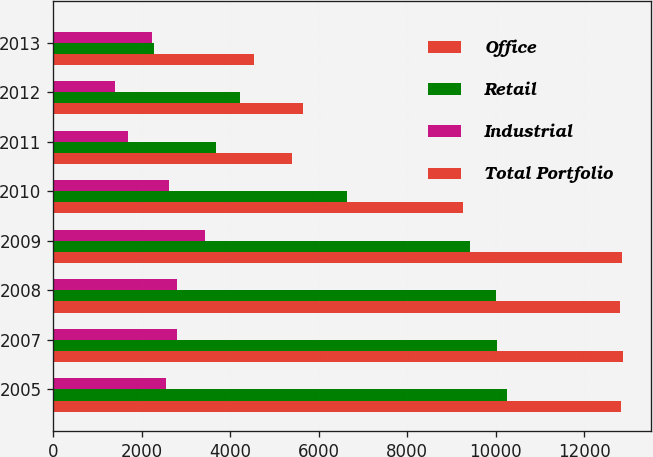Convert chart to OTSL. <chart><loc_0><loc_0><loc_500><loc_500><stacked_bar_chart><ecel><fcel>2005<fcel>2007<fcel>2008<fcel>2009<fcel>2010<fcel>2011<fcel>2012<fcel>2013<nl><fcel>Office<fcel>12820<fcel>12862<fcel>12813<fcel>12848<fcel>9257<fcel>5400<fcel>5633<fcel>4545<nl><fcel>Retail<fcel>10258<fcel>10031<fcel>9995<fcel>9420<fcel>6631<fcel>3689<fcel>4231<fcel>2269<nl><fcel>Industrial<fcel>2551<fcel>2807<fcel>2799<fcel>3420<fcel>2618<fcel>1692<fcel>1395<fcel>2244<nl><fcel>Total Portfolio<fcel>11<fcel>24<fcel>19<fcel>8<fcel>8<fcel>19<fcel>7<fcel>32<nl></chart> 